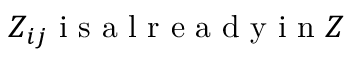<formula> <loc_0><loc_0><loc_500><loc_500>Z _ { i j } i s a l r e a d y i n Z</formula> 